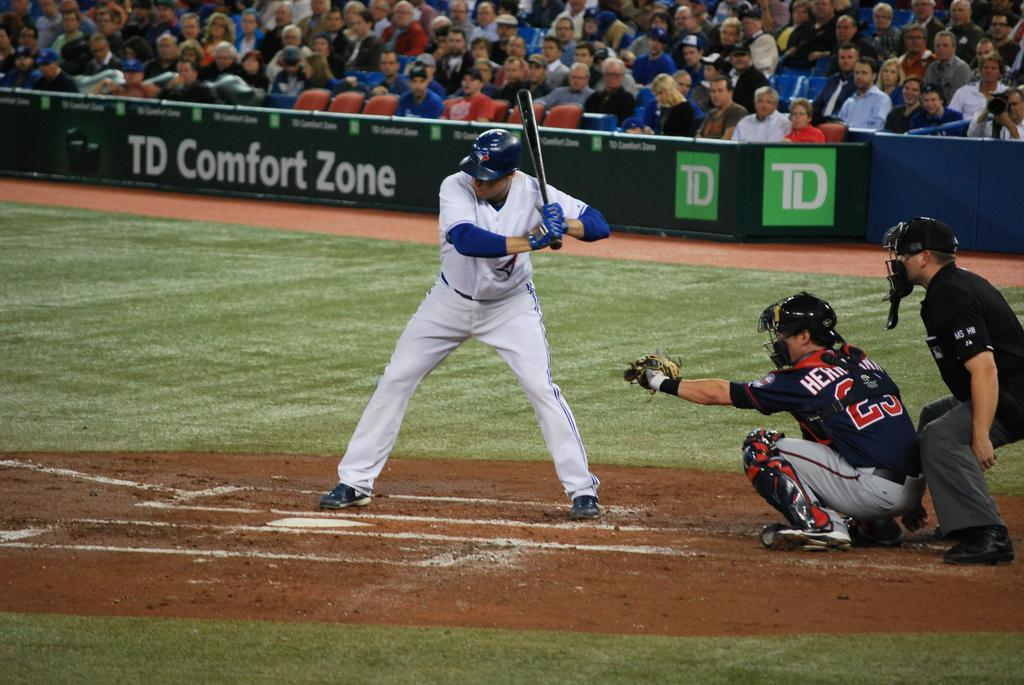Provide a one-sentence caption for the provided image. A baseball game sponsored by TD Comfort Zone. 